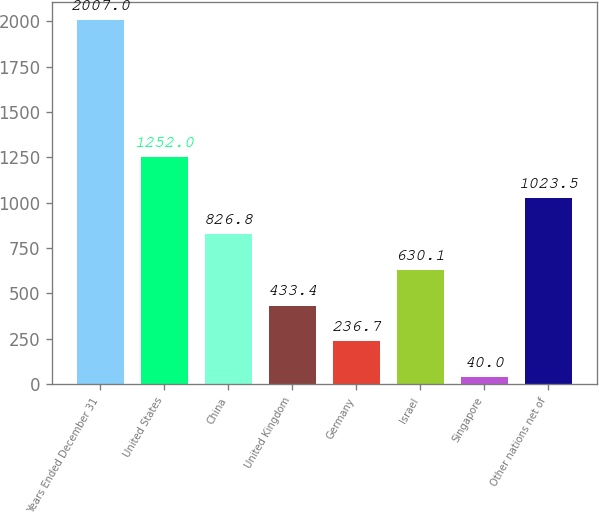Convert chart. <chart><loc_0><loc_0><loc_500><loc_500><bar_chart><fcel>Years Ended December 31<fcel>United States<fcel>China<fcel>United Kingdom<fcel>Germany<fcel>Israel<fcel>Singapore<fcel>Other nations net of<nl><fcel>2007<fcel>1252<fcel>826.8<fcel>433.4<fcel>236.7<fcel>630.1<fcel>40<fcel>1023.5<nl></chart> 